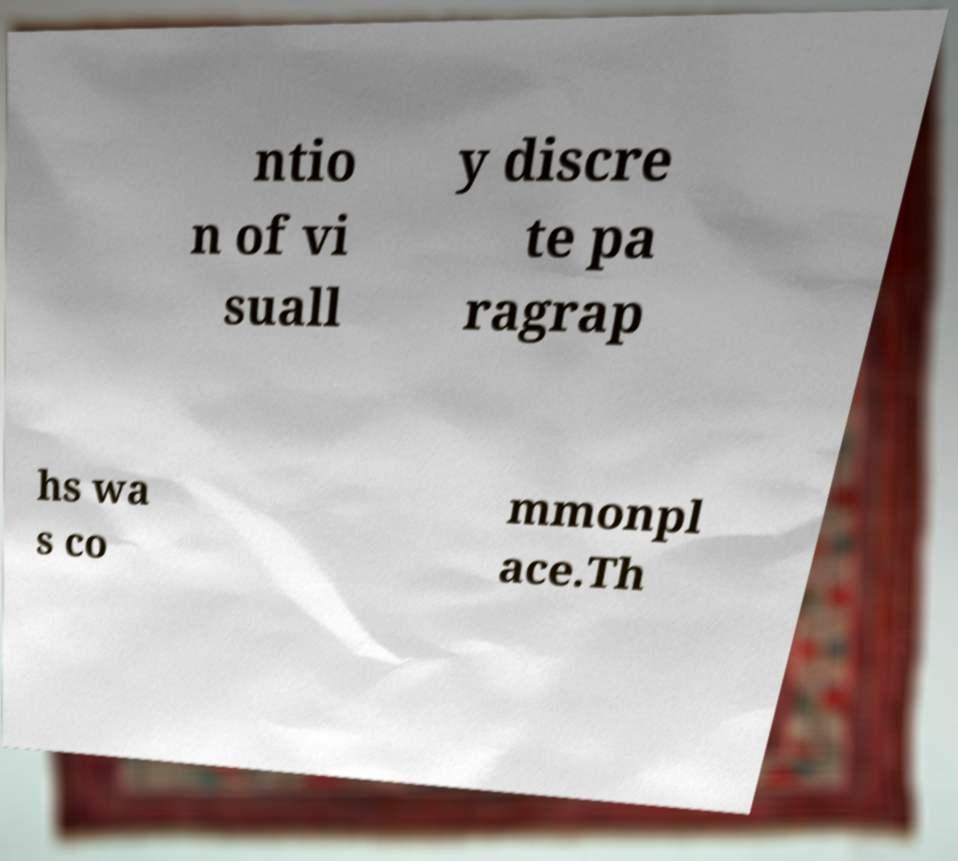Can you read and provide the text displayed in the image?This photo seems to have some interesting text. Can you extract and type it out for me? ntio n of vi suall y discre te pa ragrap hs wa s co mmonpl ace.Th 